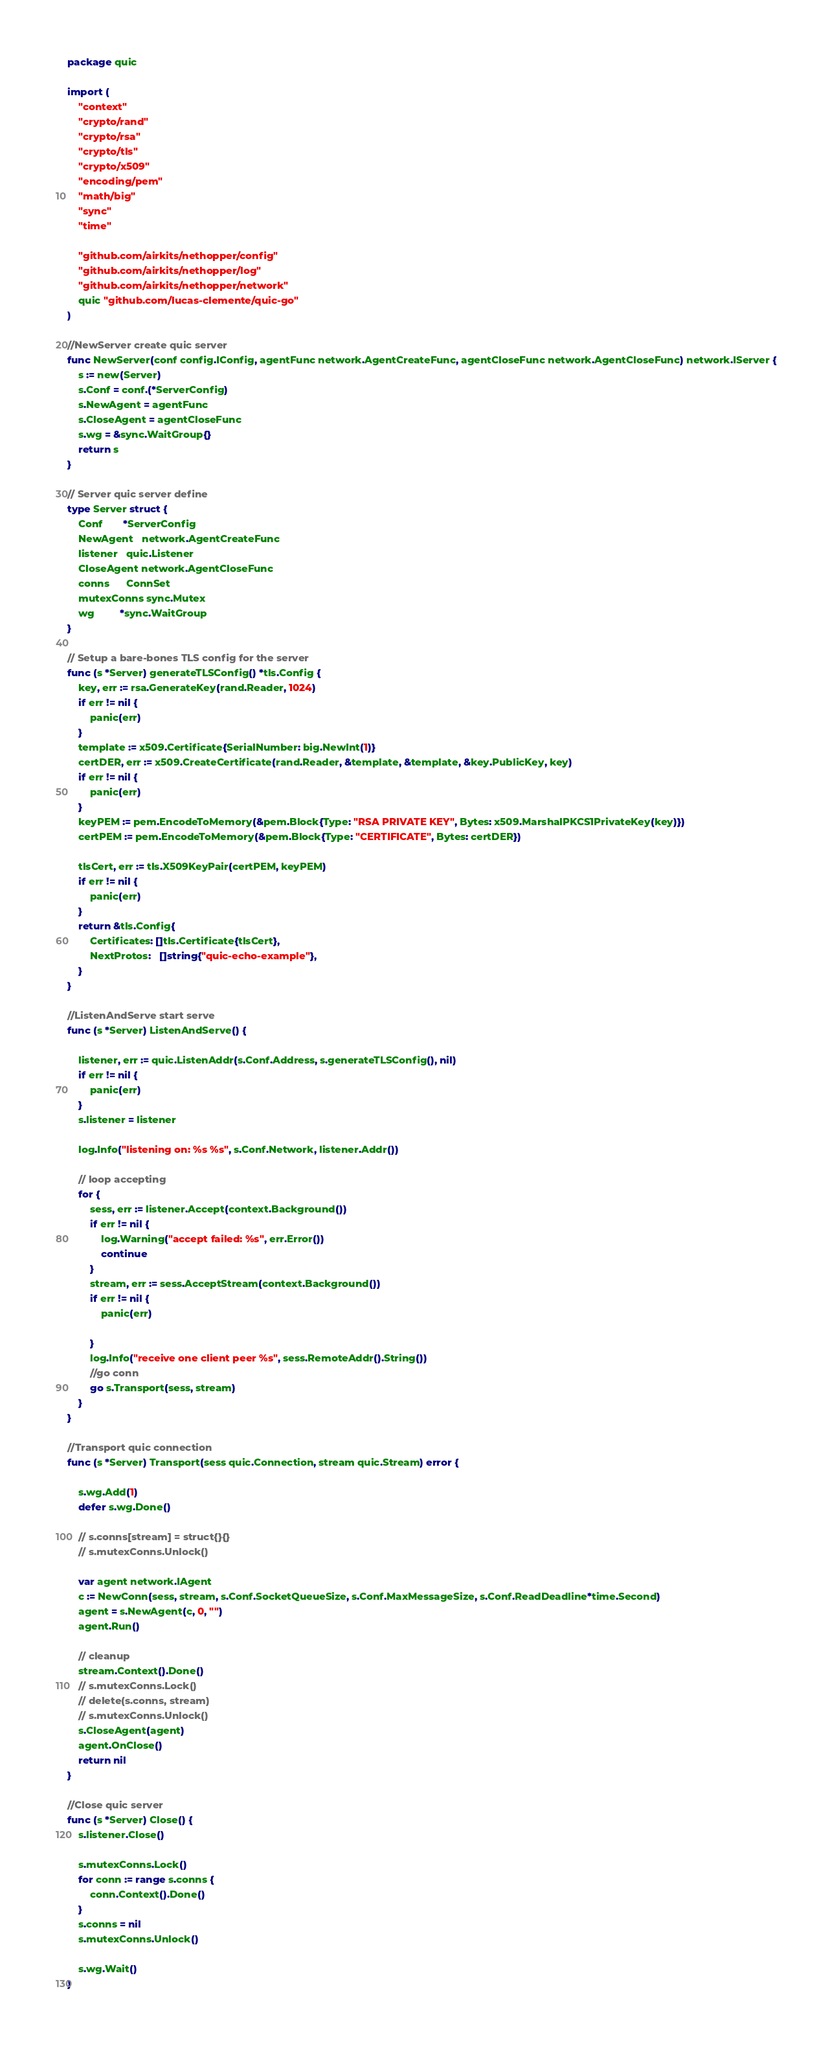<code> <loc_0><loc_0><loc_500><loc_500><_Go_>package quic

import (
	"context"
	"crypto/rand"
	"crypto/rsa"
	"crypto/tls"
	"crypto/x509"
	"encoding/pem"
	"math/big"
	"sync"
	"time"

	"github.com/airkits/nethopper/config"
	"github.com/airkits/nethopper/log"
	"github.com/airkits/nethopper/network"
	quic "github.com/lucas-clemente/quic-go"
)

//NewServer create quic server
func NewServer(conf config.IConfig, agentFunc network.AgentCreateFunc, agentCloseFunc network.AgentCloseFunc) network.IServer {
	s := new(Server)
	s.Conf = conf.(*ServerConfig)
	s.NewAgent = agentFunc
	s.CloseAgent = agentCloseFunc
	s.wg = &sync.WaitGroup{}
	return s
}

// Server quic server define
type Server struct {
	Conf       *ServerConfig
	NewAgent   network.AgentCreateFunc
	listener   quic.Listener
	CloseAgent network.AgentCloseFunc
	conns      ConnSet
	mutexConns sync.Mutex
	wg         *sync.WaitGroup
}

// Setup a bare-bones TLS config for the server
func (s *Server) generateTLSConfig() *tls.Config {
	key, err := rsa.GenerateKey(rand.Reader, 1024)
	if err != nil {
		panic(err)
	}
	template := x509.Certificate{SerialNumber: big.NewInt(1)}
	certDER, err := x509.CreateCertificate(rand.Reader, &template, &template, &key.PublicKey, key)
	if err != nil {
		panic(err)
	}
	keyPEM := pem.EncodeToMemory(&pem.Block{Type: "RSA PRIVATE KEY", Bytes: x509.MarshalPKCS1PrivateKey(key)})
	certPEM := pem.EncodeToMemory(&pem.Block{Type: "CERTIFICATE", Bytes: certDER})

	tlsCert, err := tls.X509KeyPair(certPEM, keyPEM)
	if err != nil {
		panic(err)
	}
	return &tls.Config{
		Certificates: []tls.Certificate{tlsCert},
		NextProtos:   []string{"quic-echo-example"},
	}
}

//ListenAndServe start serve
func (s *Server) ListenAndServe() {

	listener, err := quic.ListenAddr(s.Conf.Address, s.generateTLSConfig(), nil)
	if err != nil {
		panic(err)
	}
	s.listener = listener

	log.Info("listening on: %s %s", s.Conf.Network, listener.Addr())

	// loop accepting
	for {
		sess, err := listener.Accept(context.Background())
		if err != nil {
			log.Warning("accept failed: %s", err.Error())
			continue
		}
		stream, err := sess.AcceptStream(context.Background())
		if err != nil {
			panic(err)

		}
		log.Info("receive one client peer %s", sess.RemoteAddr().String())
		//go conn
		go s.Transport(sess, stream)
	}
}

//Transport quic connection
func (s *Server) Transport(sess quic.Connection, stream quic.Stream) error {

	s.wg.Add(1)
	defer s.wg.Done()

	// s.conns[stream] = struct{}{}
	// s.mutexConns.Unlock()

	var agent network.IAgent
	c := NewConn(sess, stream, s.Conf.SocketQueueSize, s.Conf.MaxMessageSize, s.Conf.ReadDeadline*time.Second)
	agent = s.NewAgent(c, 0, "")
	agent.Run()

	// cleanup
	stream.Context().Done()
	// s.mutexConns.Lock()
	// delete(s.conns, stream)
	// s.mutexConns.Unlock()
	s.CloseAgent(agent)
	agent.OnClose()
	return nil
}

//Close quic server
func (s *Server) Close() {
	s.listener.Close()

	s.mutexConns.Lock()
	for conn := range s.conns {
		conn.Context().Done()
	}
	s.conns = nil
	s.mutexConns.Unlock()

	s.wg.Wait()
}
</code> 